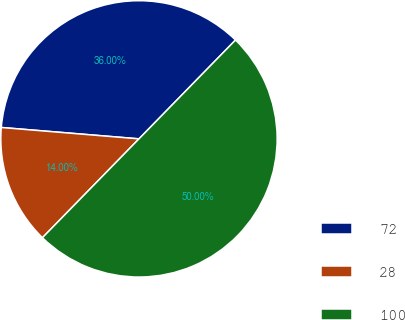Convert chart to OTSL. <chart><loc_0><loc_0><loc_500><loc_500><pie_chart><fcel>72<fcel>28<fcel>100<nl><fcel>36.0%<fcel>14.0%<fcel>50.0%<nl></chart> 